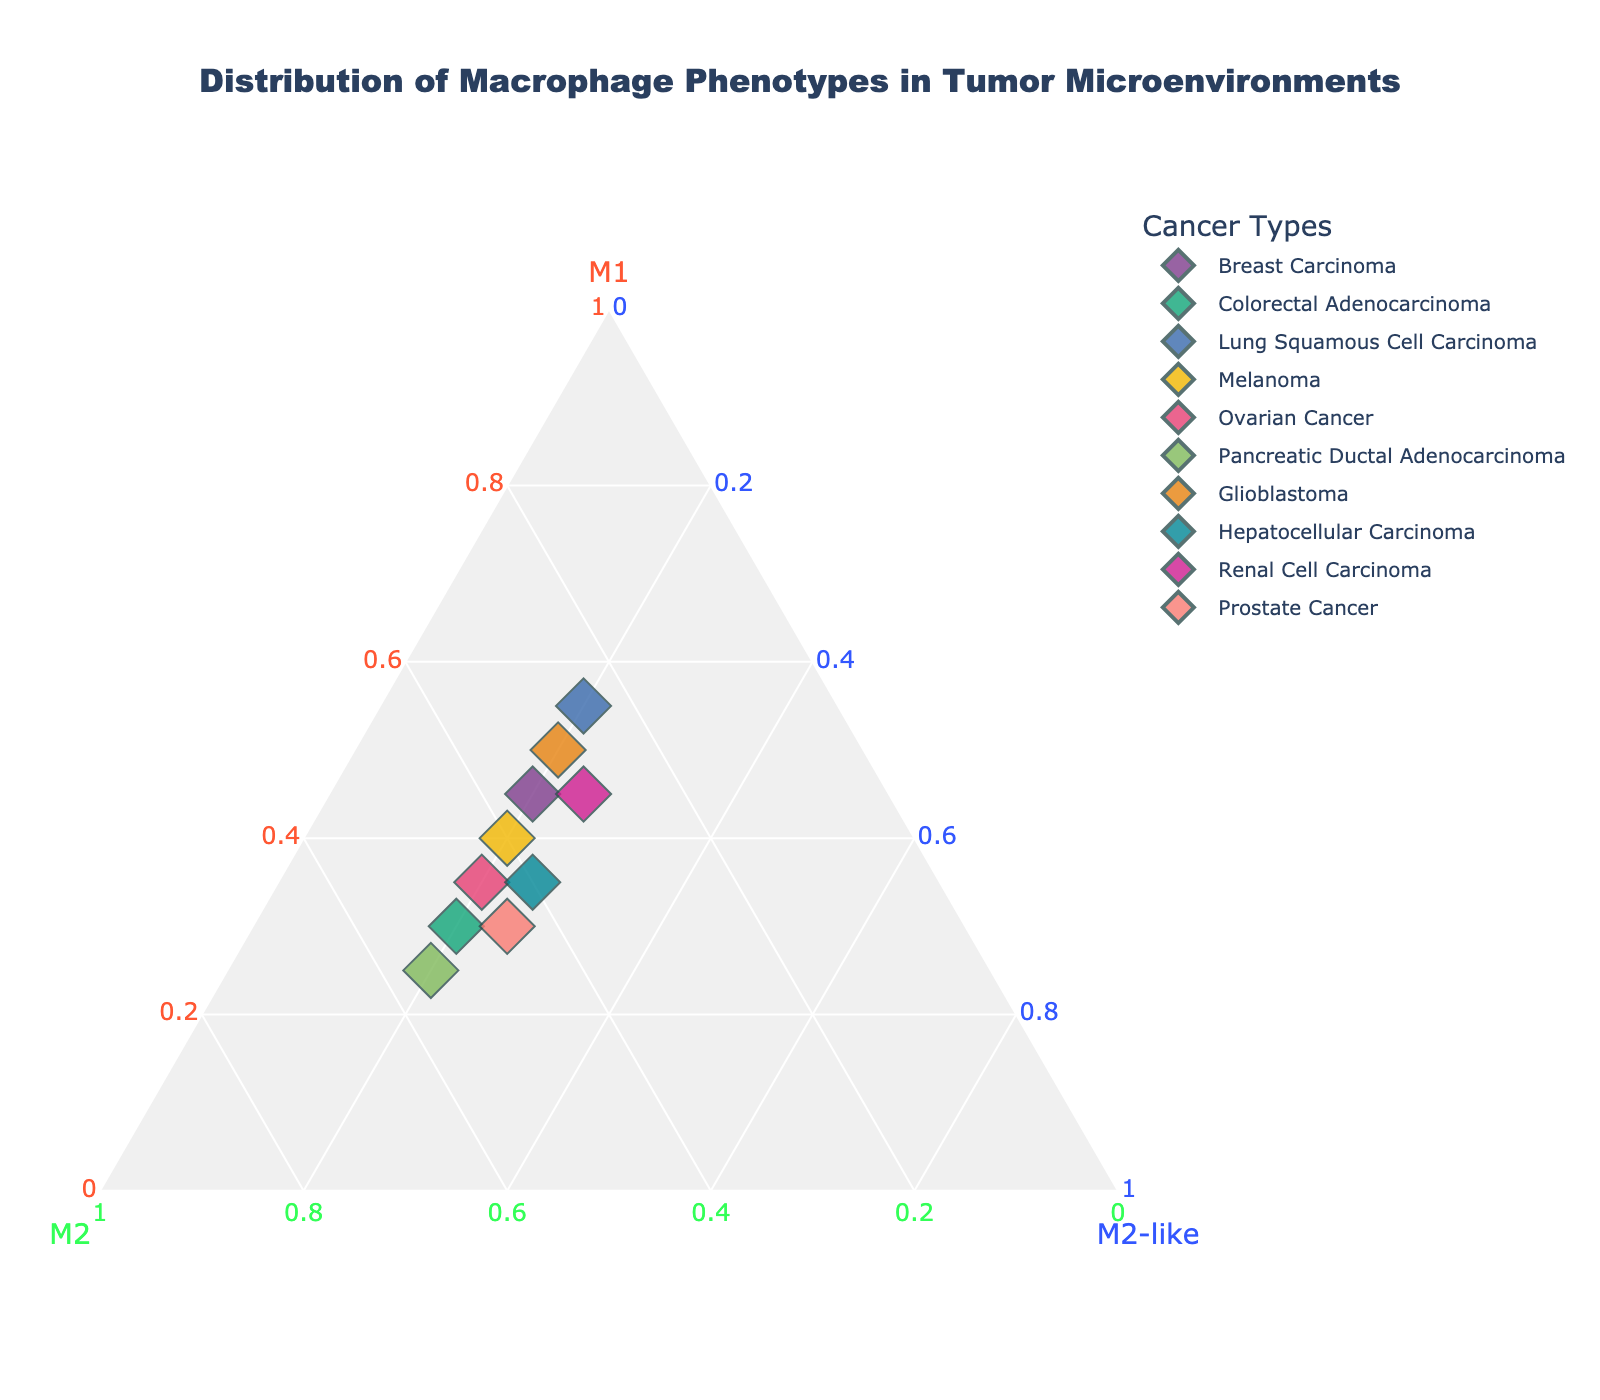What is the title of the ternary plot? The title of the ternary plot is displayed at the top of the figure. It is written in larger, bold font to attract attention.
Answer: Distribution of Macrophage Phenotypes in Tumor Microenvironments How many unique cancer types are represented in the plot? Each data point in the plot represents a different cancer type. There are ten data points.
Answer: 10 Which cancer type has the highest proportion of M1 macrophages? The point at the top corner of the ternary plot closest to the "M1" axis represents the highest proportion of M1 macrophages.
Answer: Lung Squamous Cell Carcinoma Does any sample have an equal proportion of M1 and M2 macrophages? Look for points along the line that equidistant from the M1 and M2 axes.
Answer: Melanoma Which samples have exactly 20% M2-like macrophages? Find points located along the line parallel to the M2-like axis with a percentage of 20%.
Answer: Breast Carcinoma, Colorectal Adenocarcinoma, Lung Squamous Cell Carcinoma, Melanoma, Ovarian Cancer, Pancreatic Ductal Adenocarcinoma, Glioblastoma Compare the proportion of M2 macrophages in Colorectal Adenocarcinoma and Pancreatic Ductal Adenocarcinoma. Which one is higher? Identify the positions of the points on the ternary plot. The point further along the M2 axis represents the higher proportion.
Answer: Pancreatic Ductal Adenocarcinoma What is the median proportion of M1 macrophages across all samples? Arrange the proportions of M1 macrophages in ascending order (0.25, 0.3, 0.3, 0.35, 0.35, 0.4, 0.45, 0.45, 0.5, 0.55) and find the middle value.
Answer: 0.4 Which two cancer samples have the same proportion of M2-like macrophages but differ in their M1 and M2 proportions? Identify points that share the same value along the M2-like axis and then compare their M1 and M2 values.
Answer: Hepatocellular Carcinoma and Renal Cell Carcinoma Can you determine if any sample has proportions where M1 + M2 + M2-like = 1? Examine each sample in the ternary plot. In a ternary plot, the sum of M1, M2, and M2-like always equals 1 because it represents the complete composition.
Answer: Yes, all samples Among the samples, which one has an equal or higher percentage of M1 macrophages compared to M2 macrophages? Compare the position of each point relative to the M1 and M2 axes. Points further toward the M1 axis compared to the M2 axis fulfill this condition.
Answer: Breast Carcinoma, Lung Squamous Cell Carcinoma, Glioblastoma, Renal Cell Carcinoma 